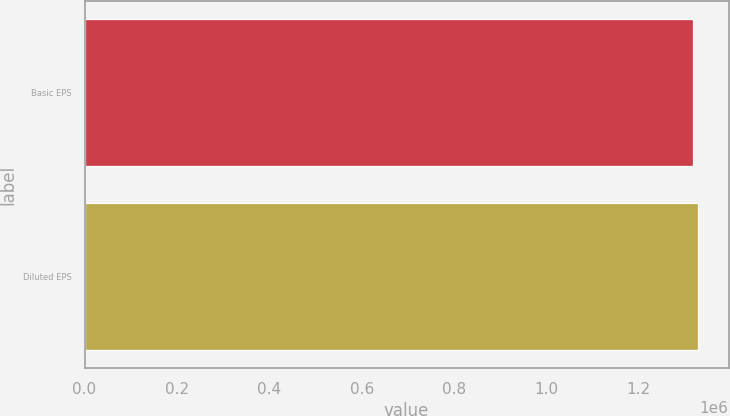Convert chart. <chart><loc_0><loc_0><loc_500><loc_500><bar_chart><fcel>Basic EPS<fcel>Diluted EPS<nl><fcel>1.31763e+06<fcel>1.328e+06<nl></chart> 